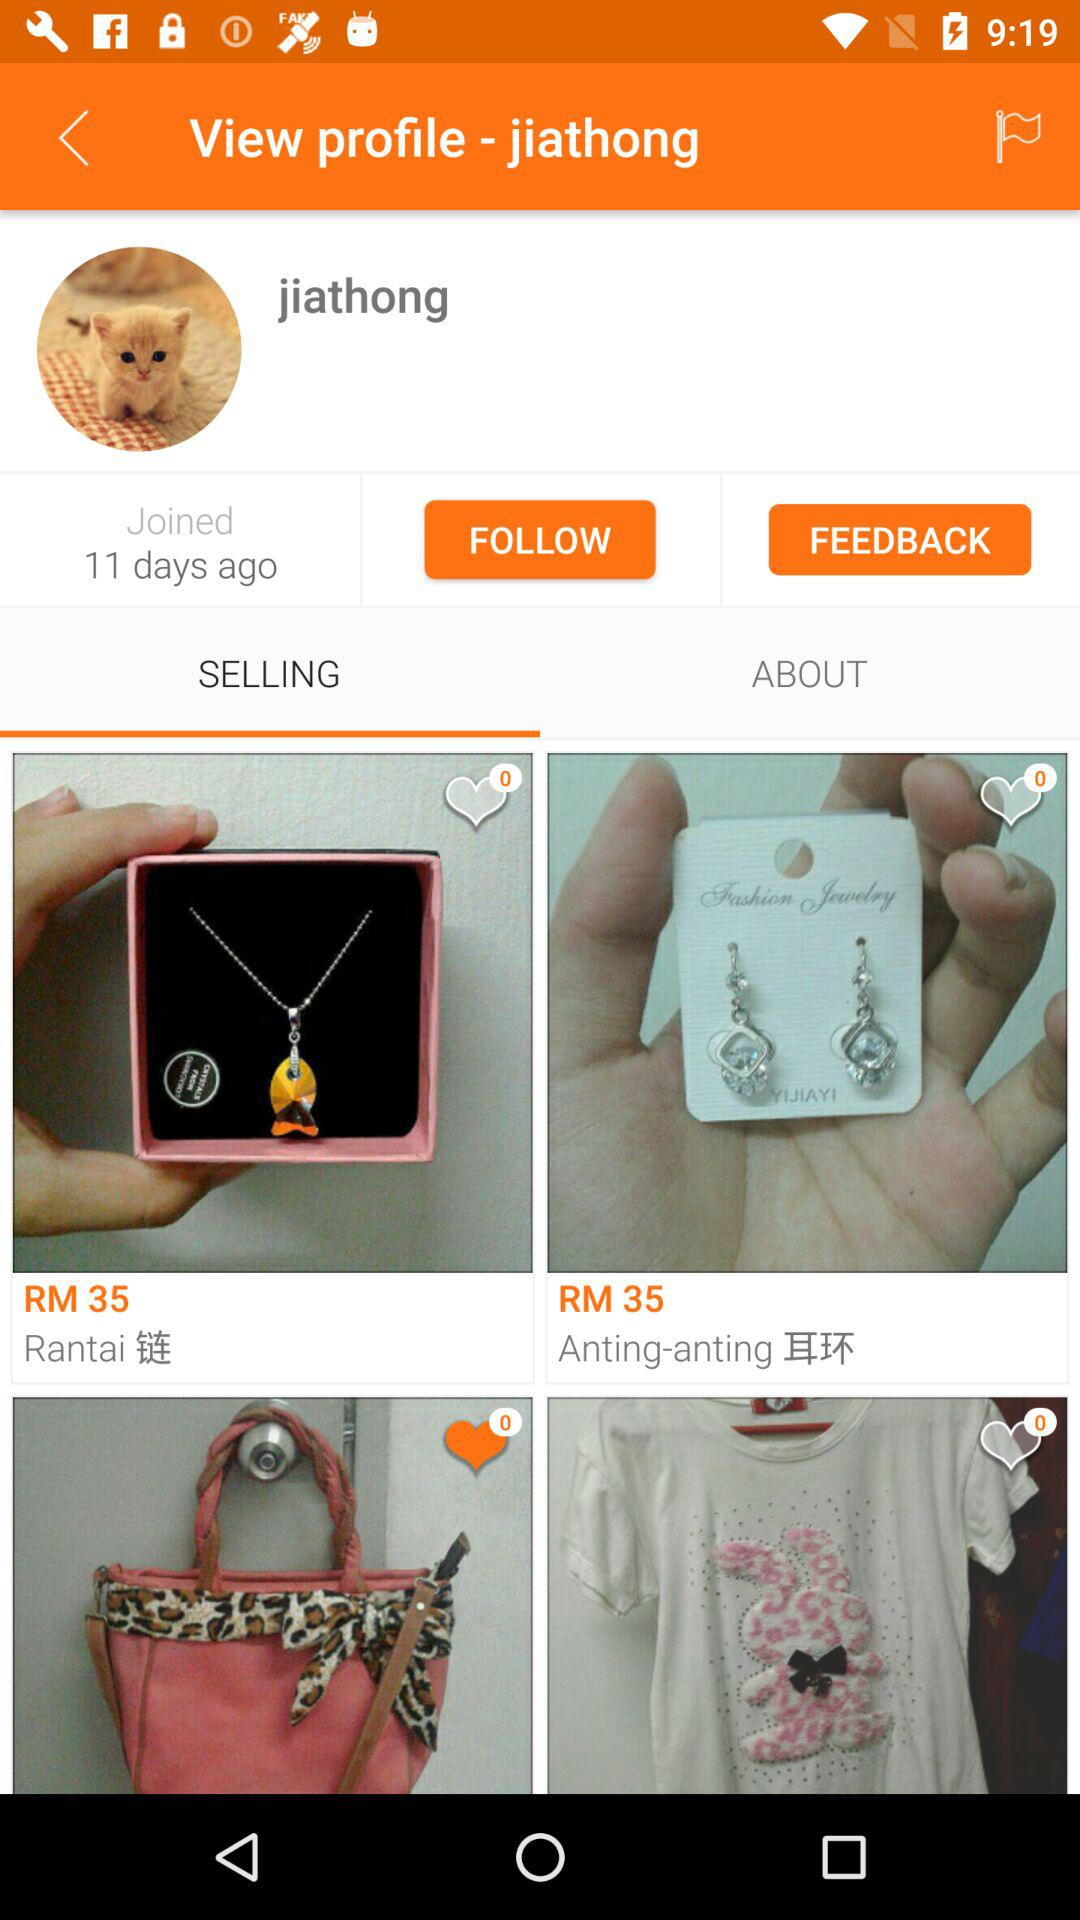What is the name of the user? The name of the user is Jiathong. 